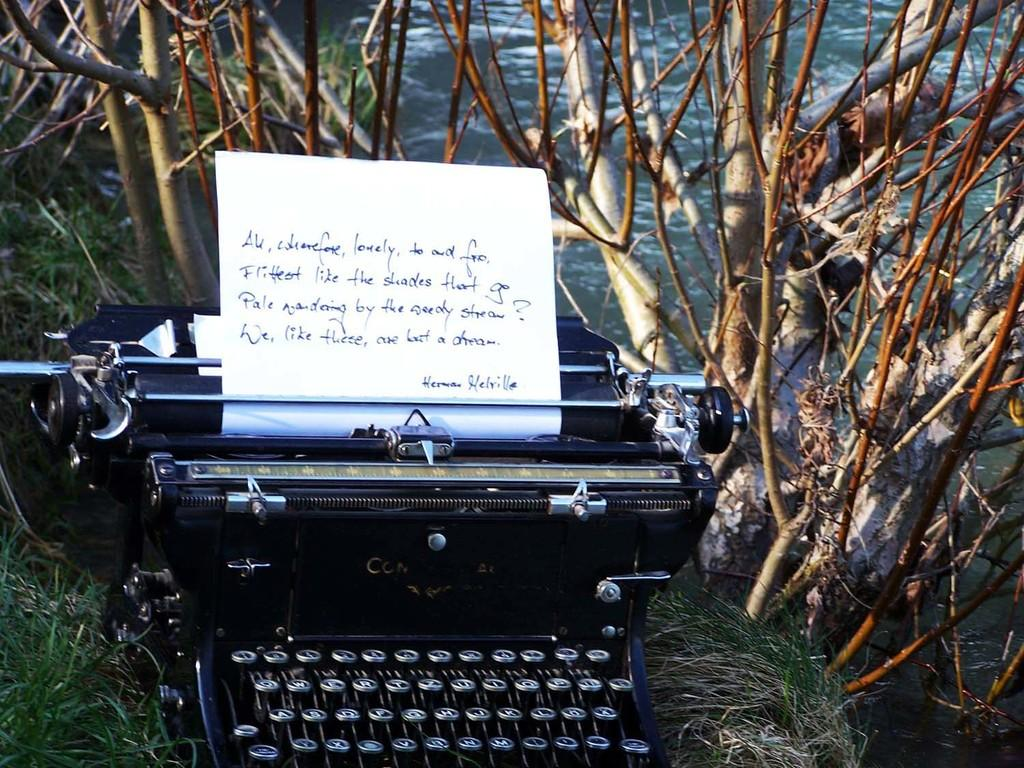<image>
Create a compact narrative representing the image presented. a typewriter that has a paper in it typed by 'hermosa helrille' 